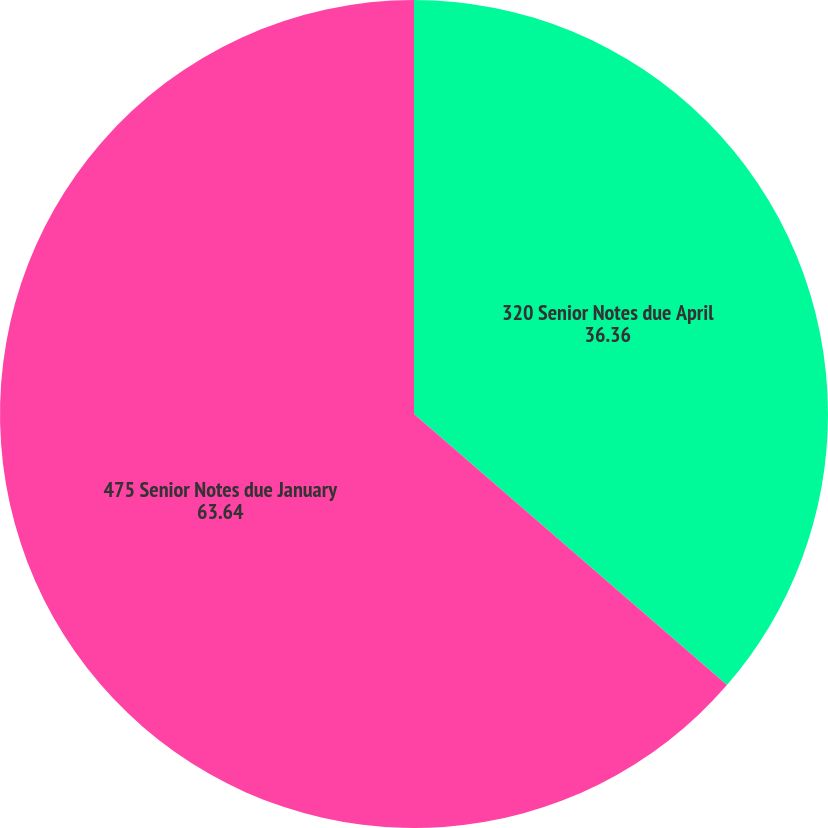<chart> <loc_0><loc_0><loc_500><loc_500><pie_chart><fcel>320 Senior Notes due April<fcel>475 Senior Notes due January<nl><fcel>36.36%<fcel>63.64%<nl></chart> 